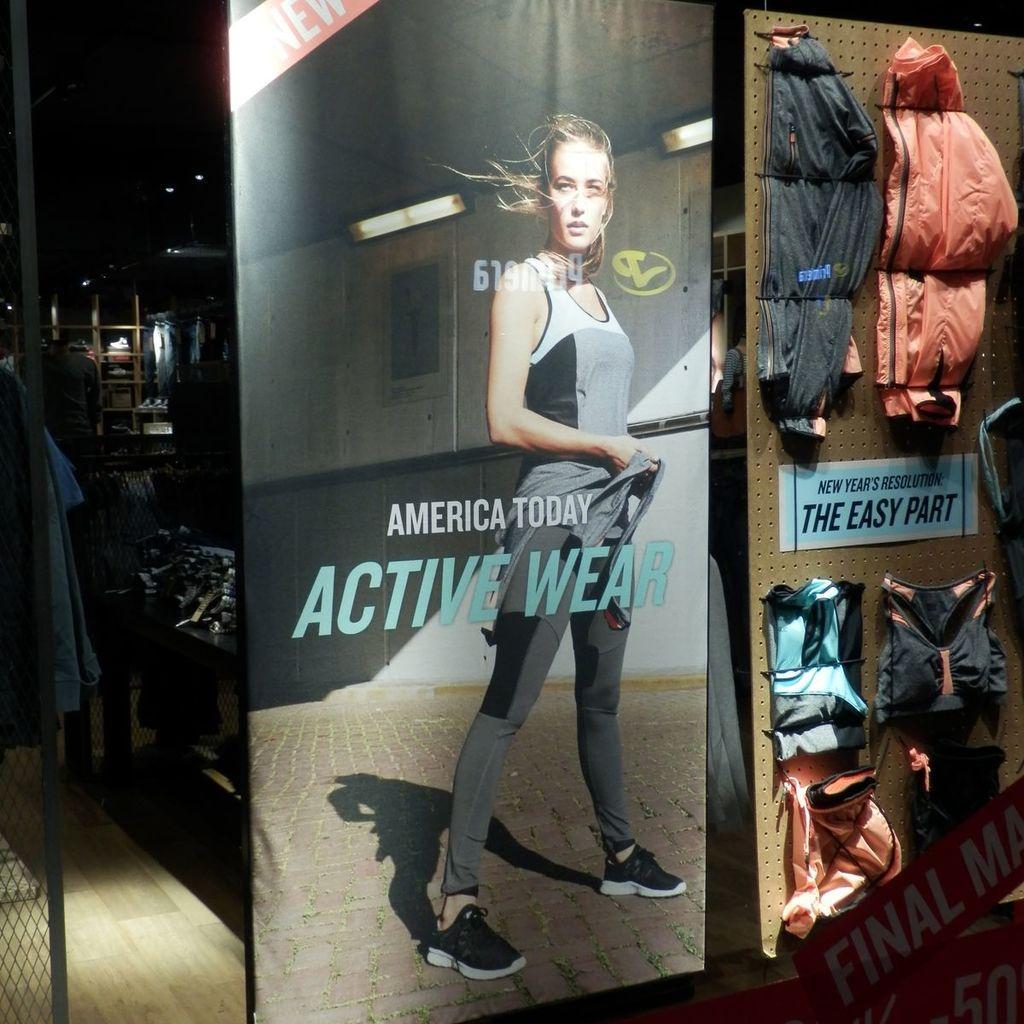In one or two sentences, can you explain what this image depicts? In the image we can see the poster, in the poster we can see the picture of the woman standing, wearing clothes and shoes, we can even see some text on the poster. Here we can see the jackets, floor, mesh and the background is dark. 